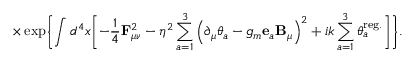<formula> <loc_0><loc_0><loc_500><loc_500>\times \exp \left \{ \int d ^ { 4 } x \left [ - \frac { 1 } { 4 } { F } _ { \mu \nu } ^ { 2 } - \eta ^ { 2 } \sum _ { a = 1 } ^ { 3 } \left ( \partial _ { \mu } \theta _ { a } - g _ { m } { e } _ { a } { B } _ { \mu } \right ) ^ { 2 } + i k \sum _ { a = 1 } ^ { 3 } \theta _ { a } ^ { r e g . } \right ] \right \} .</formula> 